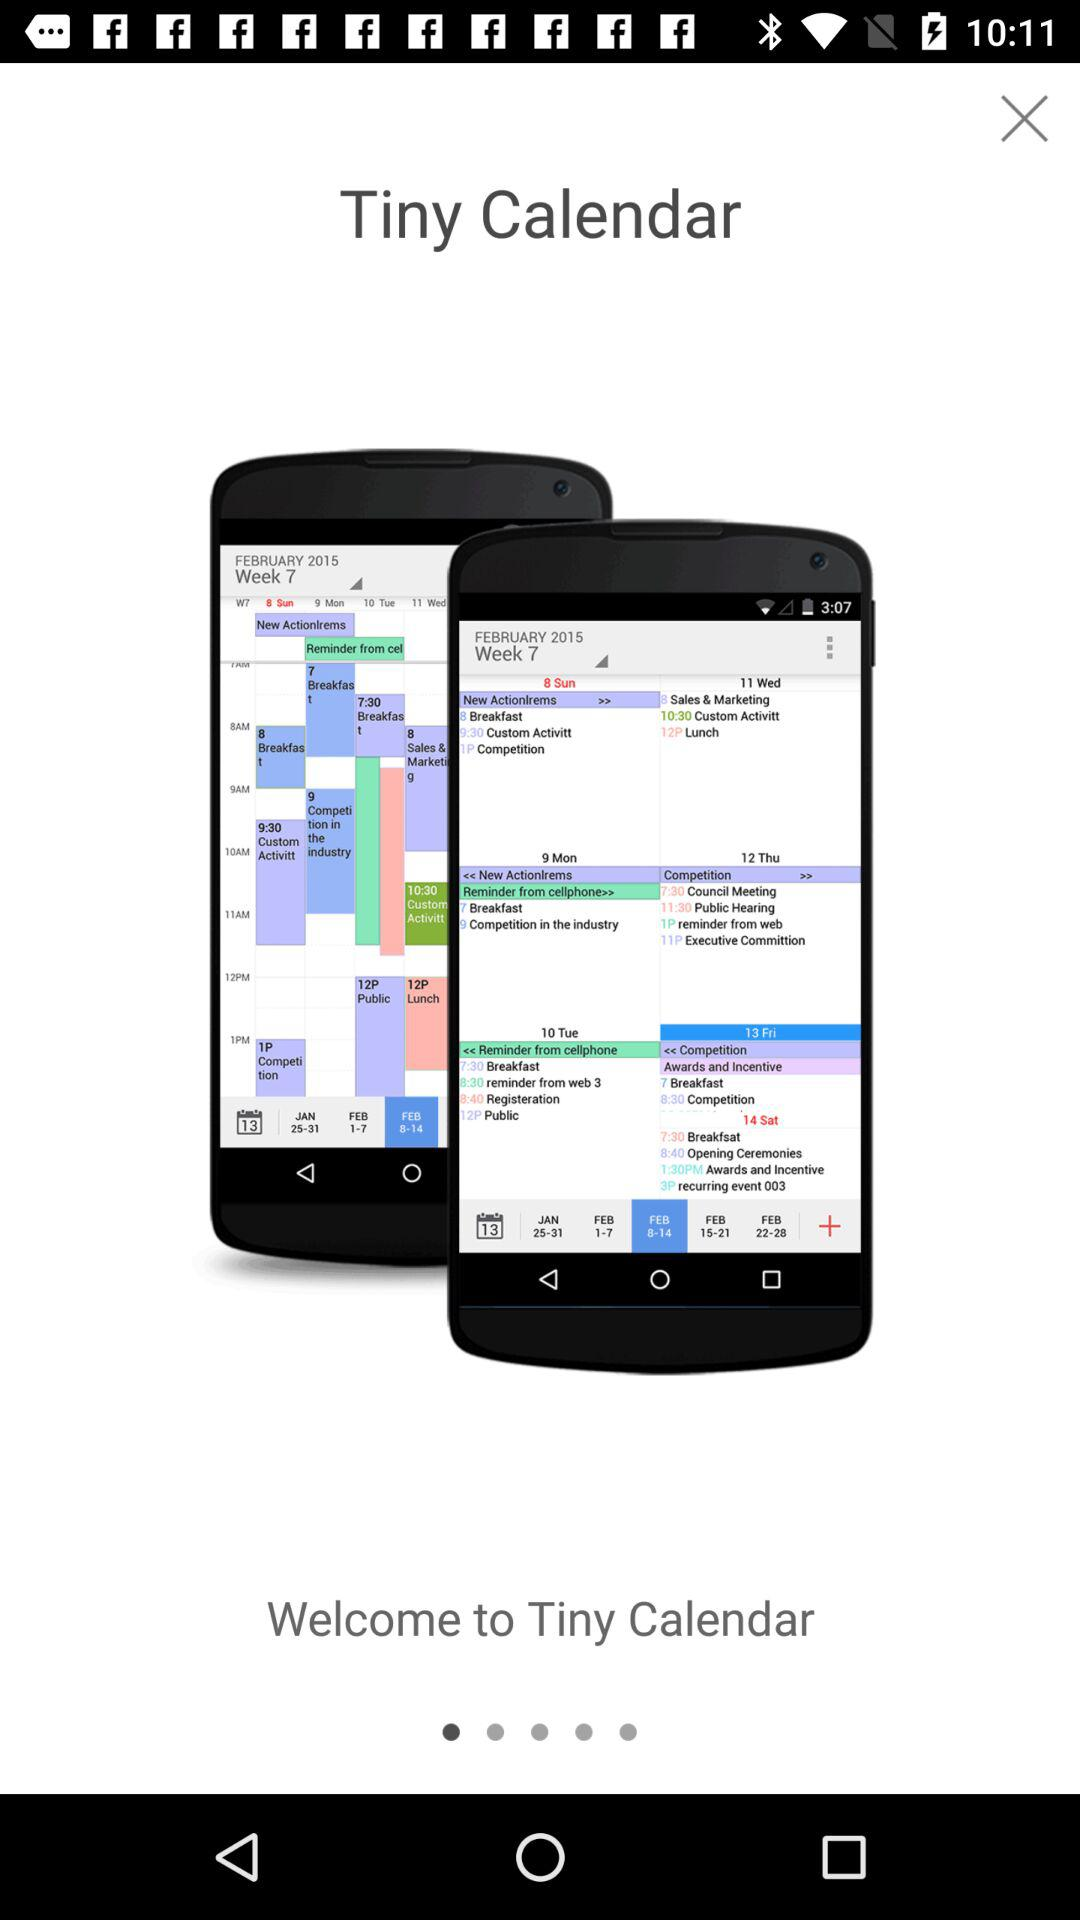What is the name of the application? The name of the application is "Tiny Calendar". 